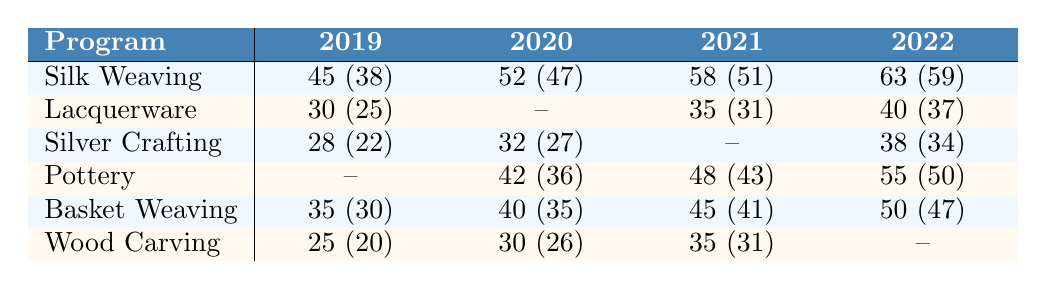What was the completion rate for Silk Weaving in 2021? The enrollment for Silk Weaving in 2021 was 58, with a completion of 51. To find the completion rate, divide the completion by enrollment: (51/58) * 100 = 87.93%.
Answer: 87.93% Which program had the highest enrollment in 2022? In 2022, Silk Weaving had the highest enrollment with 63.
Answer: Silk Weaving What is the average enrollment for Basket Weaving over the years? The enrollment for Basket Weaving is: 35 (2019), 40 (2020), 45 (2021), and 50 (2022). Adding these values gives 35 + 40 + 45 + 50 = 170. There are 4 data points, so the average is 170/4 = 42.5.
Answer: 42.5 Did Pottery have a completion rate higher than 75% in 2022? The enrollment for Pottery in 2022 was 55 with a completion of 50. To find the completion rate, (50/55) * 100 = 90.91%, which is higher than 75%.
Answer: Yes What was the total enrollment across all programs in 2020? For 2020, the enrollments were: Silk Weaving (52), Lacquerware (30), Silver Crafting (32), Pottery (42), Basket Weaving (40), and Wood Carving (30). Adding these up: 52 + 30 + 32 + 42 + 40 + 30 = 226.
Answer: 226 Which program had the lowest completion rate in 2019? In 2019, the completion rates were: Silk Weaving (84.44%), Lacquerware (83.33%), Silver Crafting (78.57%), Basket Weaving (85.71%), and Wood Carving (80%). Silver Crafting had the lowest completion rate at 78.57%.
Answer: Silver Crafting How many completions were recorded for Silver Crafting in 2022? The enrollment for Silver Crafting in 2022 was 38, with a completion of 34. Therefore, there were 34 completions.
Answer: 34 Was the enrollment for Wood Carving consistent between 2019 and 2021? The enrollments were: 25 (2019), 30 (2020), and 35 (2021). Since the enrollment increased each year, it was not consistent.
Answer: No What is the difference in enrollment between Silk Weaving in 2019 and 2022? The enrollment for Silk Weaving was 45 in 2019 and 63 in 2022. The difference is 63 - 45 = 18.
Answer: 18 Which program had a completion rate decrease from 2019 to 2020? The only program that had data for both years is Lacquerware, with a completion of 25 in 2019 and no data for 2020, therefore showing no completion rate for that year.
Answer: No program had a decrease 